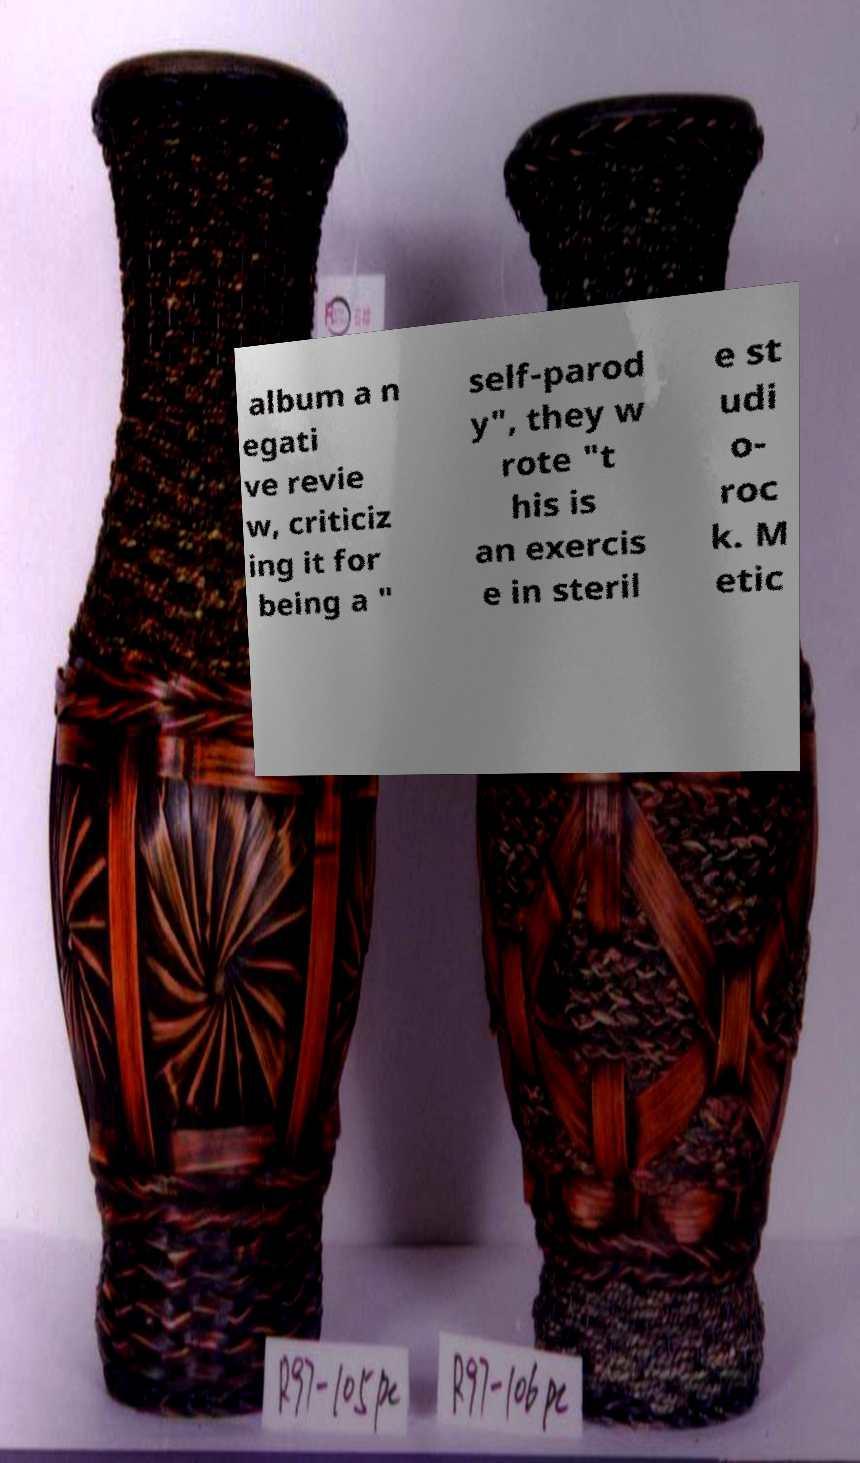I need the written content from this picture converted into text. Can you do that? album a n egati ve revie w, criticiz ing it for being a " self-parod y", they w rote "t his is an exercis e in steril e st udi o- roc k. M etic 